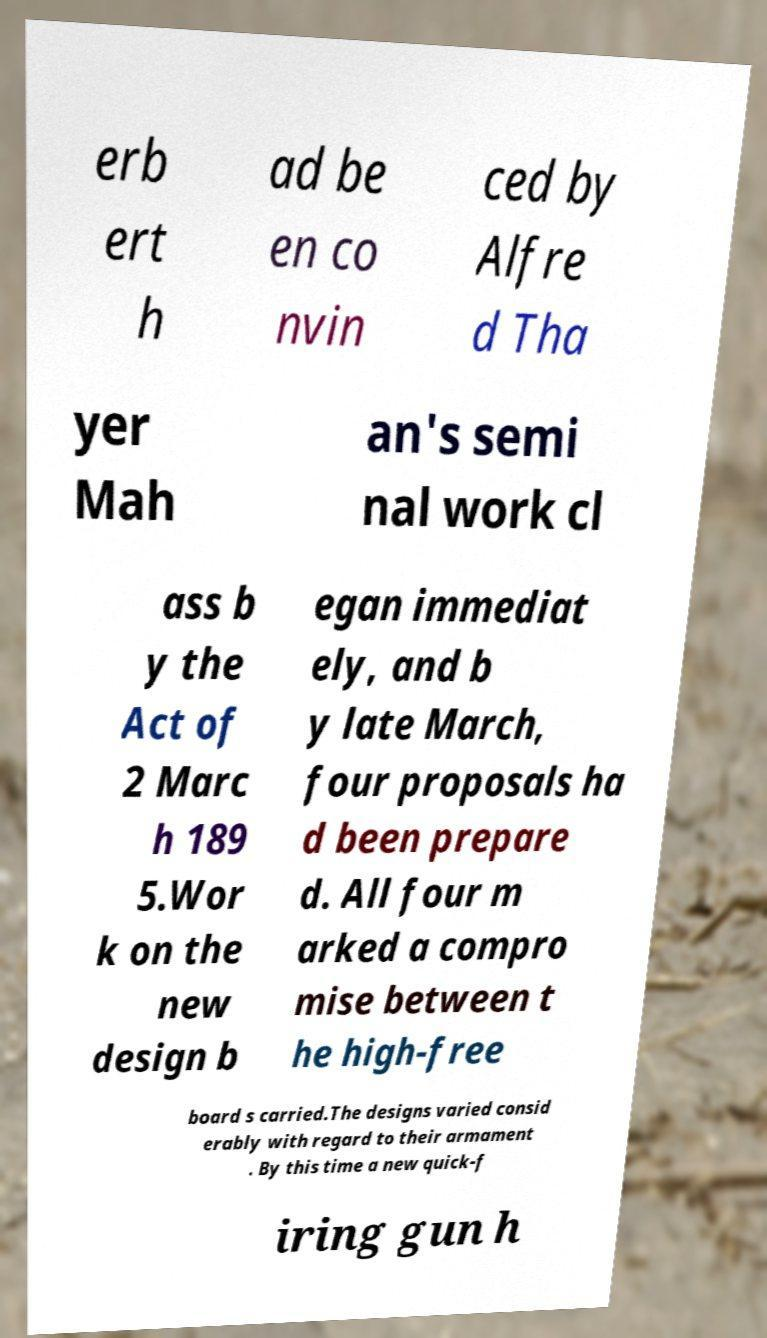Please read and relay the text visible in this image. What does it say? erb ert h ad be en co nvin ced by Alfre d Tha yer Mah an's semi nal work cl ass b y the Act of 2 Marc h 189 5.Wor k on the new design b egan immediat ely, and b y late March, four proposals ha d been prepare d. All four m arked a compro mise between t he high-free board s carried.The designs varied consid erably with regard to their armament . By this time a new quick-f iring gun h 